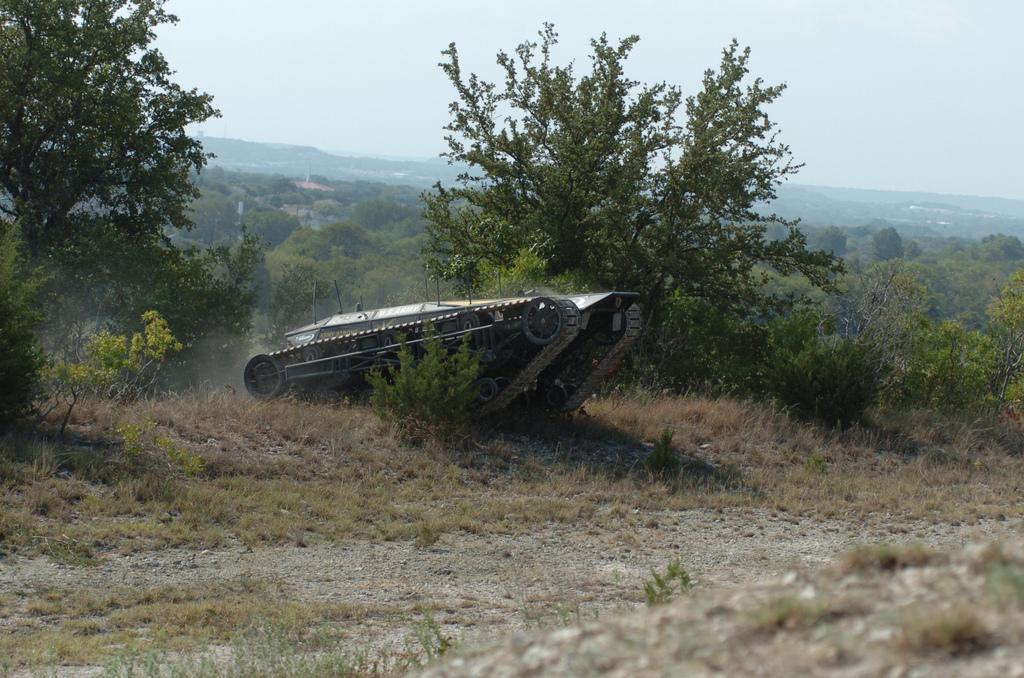Describe this image in one or two sentences. In this image I can see the grass. I can see a tank. In the background, I can see the trees and the sky. 